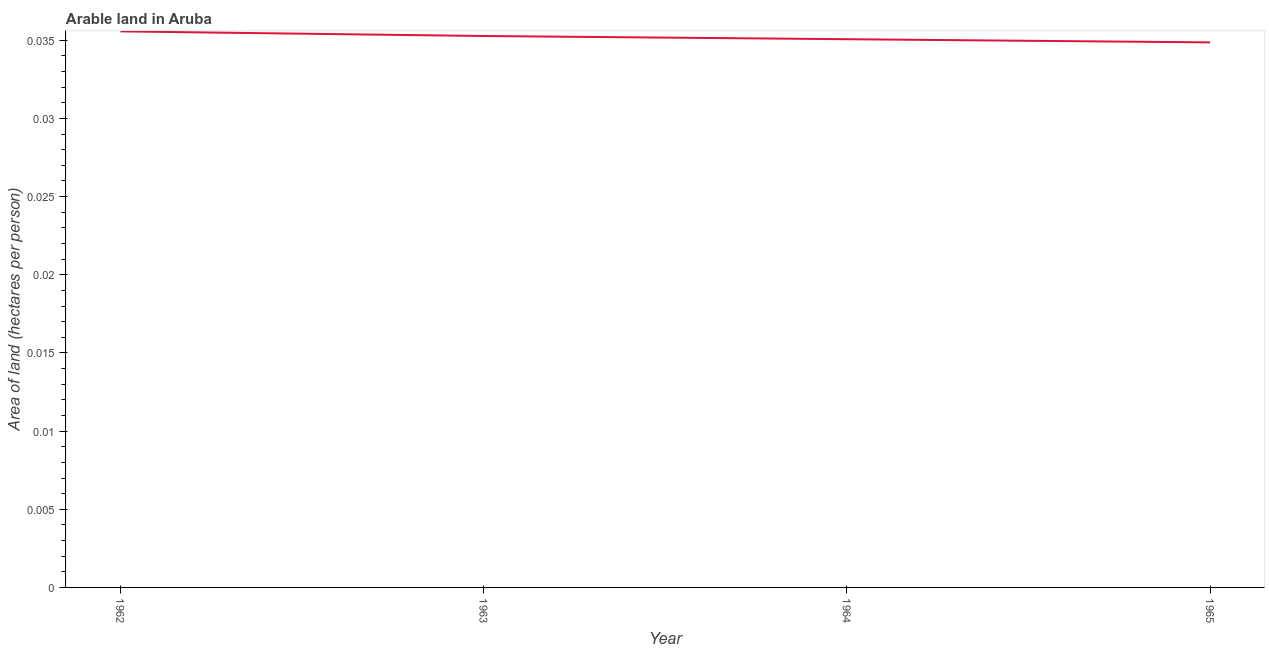What is the area of arable land in 1962?
Provide a short and direct response. 0.04. Across all years, what is the maximum area of arable land?
Provide a short and direct response. 0.04. Across all years, what is the minimum area of arable land?
Provide a short and direct response. 0.03. In which year was the area of arable land minimum?
Make the answer very short. 1965. What is the sum of the area of arable land?
Your response must be concise. 0.14. What is the difference between the area of arable land in 1963 and 1965?
Your answer should be very brief. 0. What is the average area of arable land per year?
Provide a succinct answer. 0.04. What is the median area of arable land?
Ensure brevity in your answer.  0.04. In how many years, is the area of arable land greater than 0.029 hectares per person?
Offer a very short reply. 4. Do a majority of the years between 1962 and 1965 (inclusive) have area of arable land greater than 0.018 hectares per person?
Offer a very short reply. Yes. What is the ratio of the area of arable land in 1962 to that in 1965?
Provide a short and direct response. 1.02. Is the area of arable land in 1962 less than that in 1963?
Give a very brief answer. No. What is the difference between the highest and the second highest area of arable land?
Provide a succinct answer. 0. Is the sum of the area of arable land in 1962 and 1964 greater than the maximum area of arable land across all years?
Your response must be concise. Yes. What is the difference between the highest and the lowest area of arable land?
Provide a short and direct response. 0. Does the area of arable land monotonically increase over the years?
Your response must be concise. No. What is the difference between two consecutive major ticks on the Y-axis?
Your answer should be very brief. 0.01. Are the values on the major ticks of Y-axis written in scientific E-notation?
Offer a very short reply. No. Does the graph contain grids?
Your answer should be compact. No. What is the title of the graph?
Keep it short and to the point. Arable land in Aruba. What is the label or title of the X-axis?
Your answer should be very brief. Year. What is the label or title of the Y-axis?
Your response must be concise. Area of land (hectares per person). What is the Area of land (hectares per person) of 1962?
Provide a succinct answer. 0.04. What is the Area of land (hectares per person) in 1963?
Make the answer very short. 0.04. What is the Area of land (hectares per person) in 1964?
Offer a terse response. 0.04. What is the Area of land (hectares per person) in 1965?
Give a very brief answer. 0.03. What is the difference between the Area of land (hectares per person) in 1962 and 1963?
Your response must be concise. 0. What is the difference between the Area of land (hectares per person) in 1962 and 1964?
Provide a succinct answer. 0. What is the difference between the Area of land (hectares per person) in 1962 and 1965?
Provide a short and direct response. 0. What is the difference between the Area of land (hectares per person) in 1963 and 1964?
Keep it short and to the point. 0. What is the difference between the Area of land (hectares per person) in 1963 and 1965?
Offer a very short reply. 0. What is the difference between the Area of land (hectares per person) in 1964 and 1965?
Your response must be concise. 0. What is the ratio of the Area of land (hectares per person) in 1963 to that in 1964?
Provide a short and direct response. 1.01. 